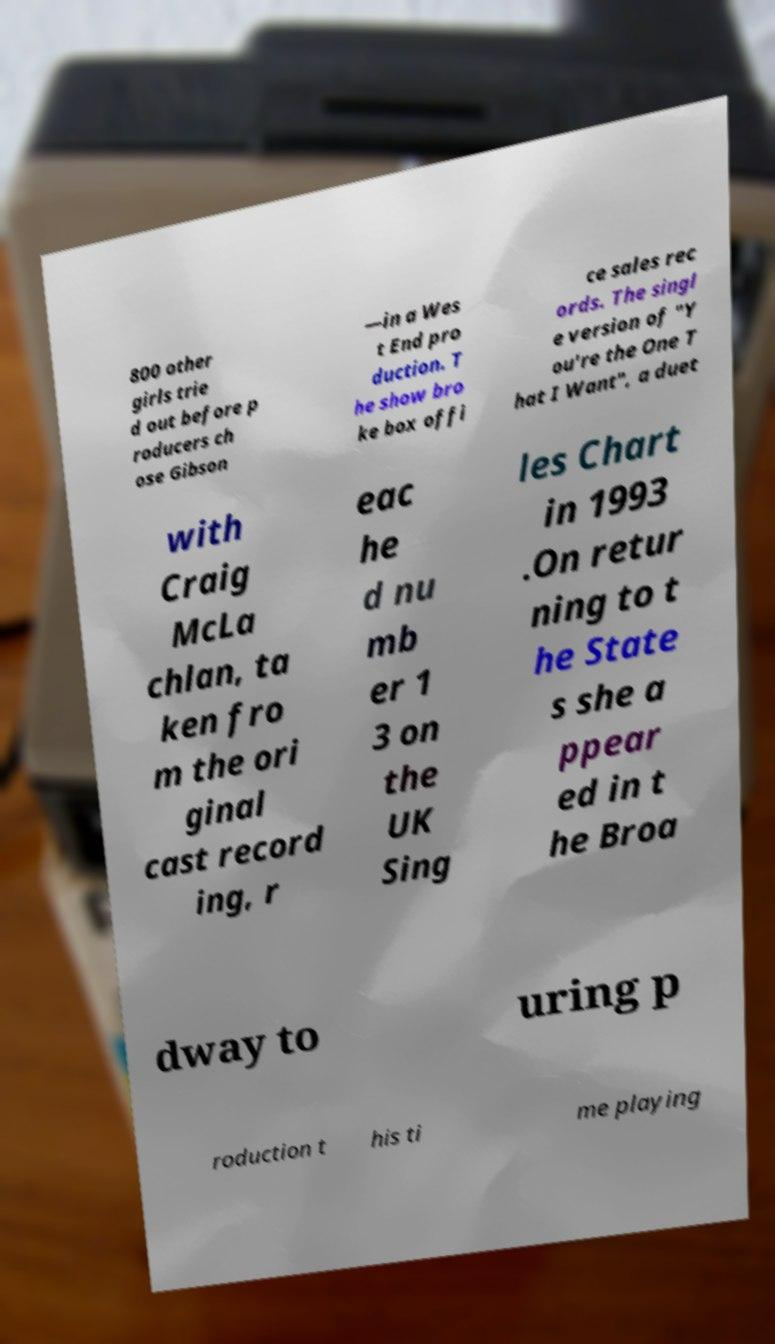Can you accurately transcribe the text from the provided image for me? 800 other girls trie d out before p roducers ch ose Gibson —in a Wes t End pro duction. T he show bro ke box offi ce sales rec ords. The singl e version of "Y ou're the One T hat I Want", a duet with Craig McLa chlan, ta ken fro m the ori ginal cast record ing, r eac he d nu mb er 1 3 on the UK Sing les Chart in 1993 .On retur ning to t he State s she a ppear ed in t he Broa dway to uring p roduction t his ti me playing 